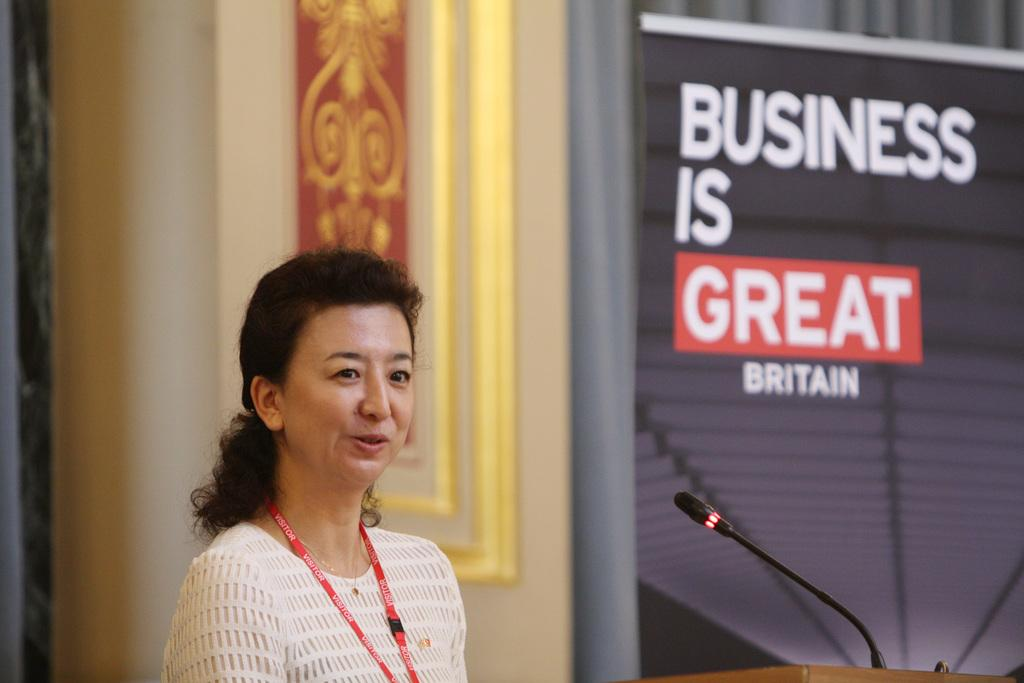Who is present in the image? There is a woman in the image. What is the woman wearing? The woman is wearing a tag. What can be seen in the background of the image? There is a frame, a wall, and a banner in the background of the image. What architectural feature is on the left side of the image? There is a pillar on the left side of the image. What object is present for communication purposes? There is a microphone (mike) in the image. How many dolls are playing in the park in the image? There are no dolls or park present in the image. 